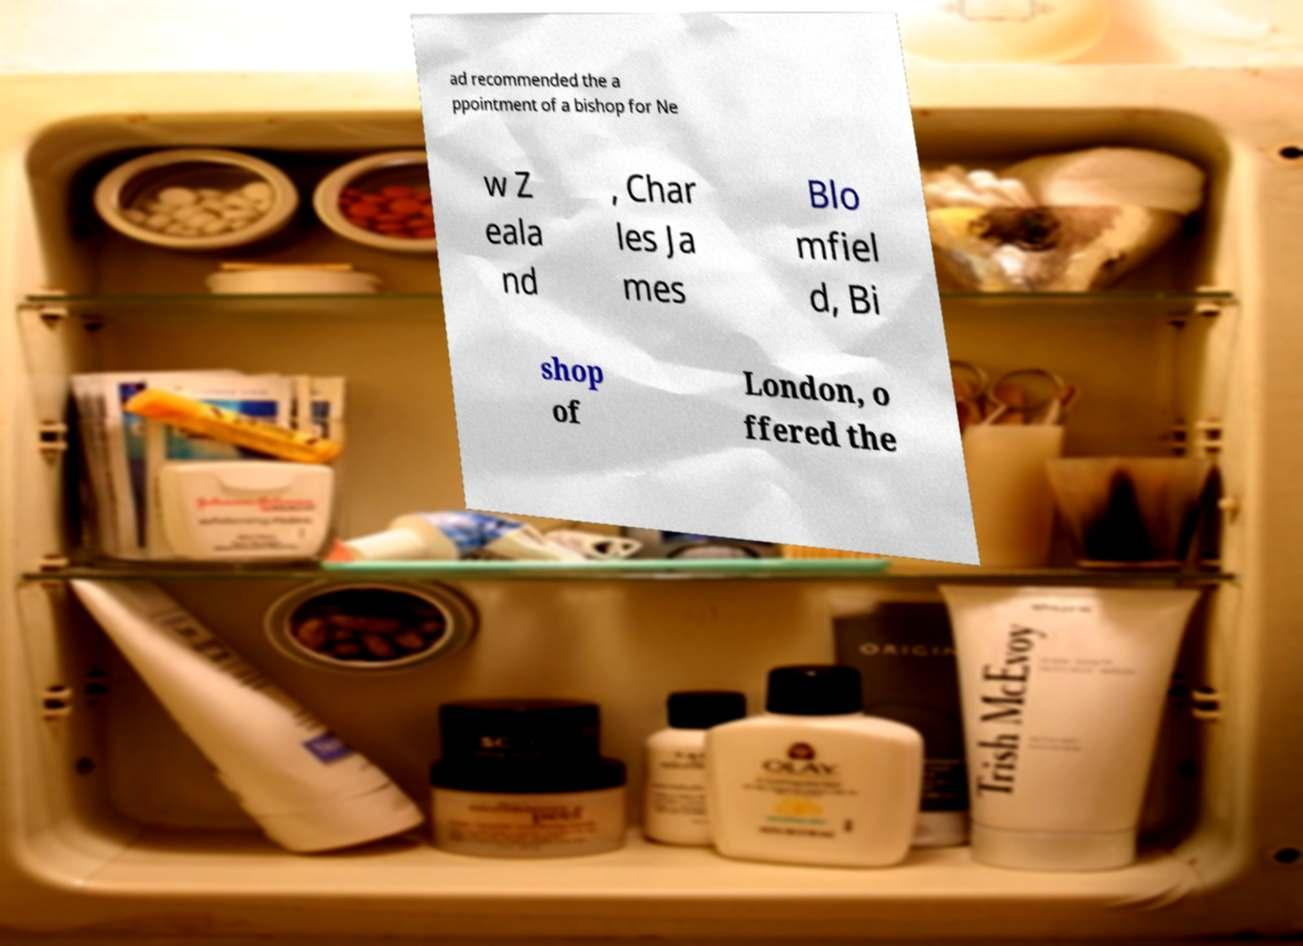Please read and relay the text visible in this image. What does it say? ad recommended the a ppointment of a bishop for Ne w Z eala nd , Char les Ja mes Blo mfiel d, Bi shop of London, o ffered the 